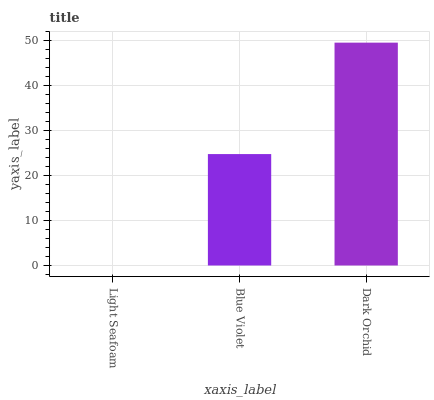Is Light Seafoam the minimum?
Answer yes or no. Yes. Is Dark Orchid the maximum?
Answer yes or no. Yes. Is Blue Violet the minimum?
Answer yes or no. No. Is Blue Violet the maximum?
Answer yes or no. No. Is Blue Violet greater than Light Seafoam?
Answer yes or no. Yes. Is Light Seafoam less than Blue Violet?
Answer yes or no. Yes. Is Light Seafoam greater than Blue Violet?
Answer yes or no. No. Is Blue Violet less than Light Seafoam?
Answer yes or no. No. Is Blue Violet the high median?
Answer yes or no. Yes. Is Blue Violet the low median?
Answer yes or no. Yes. Is Dark Orchid the high median?
Answer yes or no. No. Is Light Seafoam the low median?
Answer yes or no. No. 